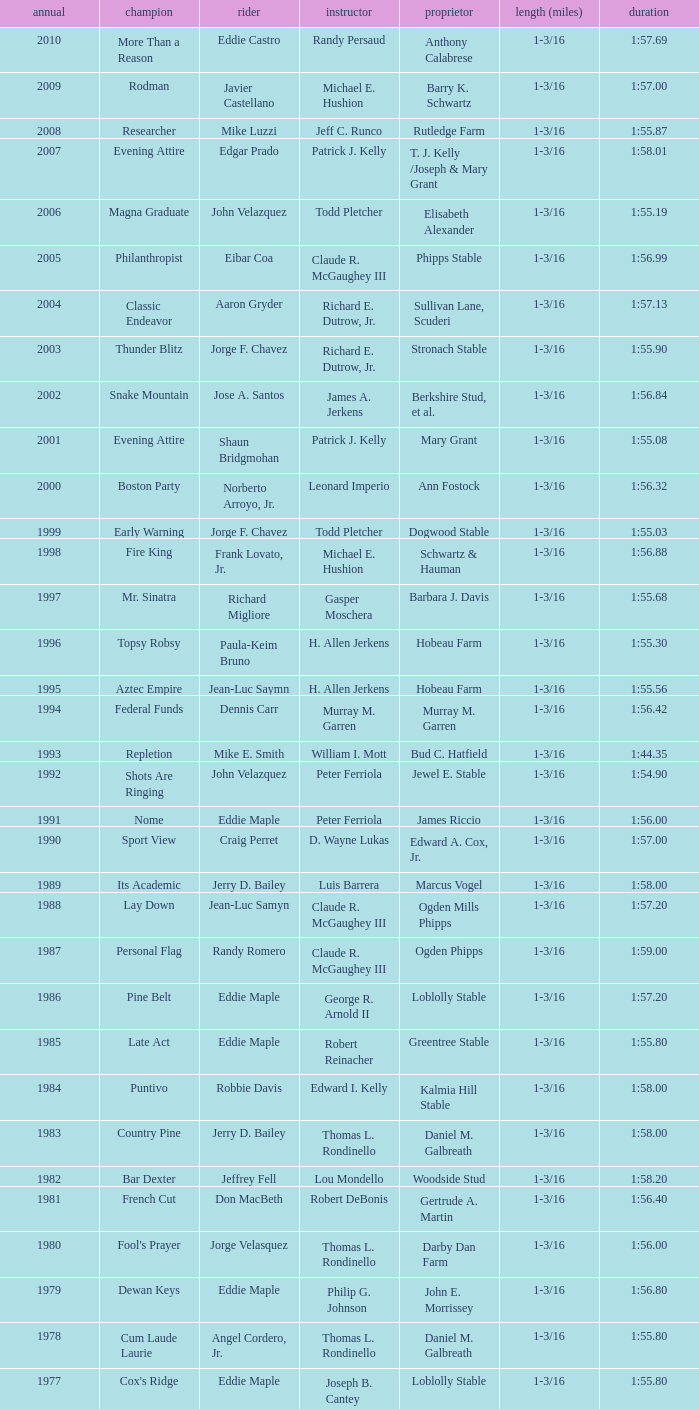What was the winning time for the winning horse, Kentucky ii? 1:38.80. 